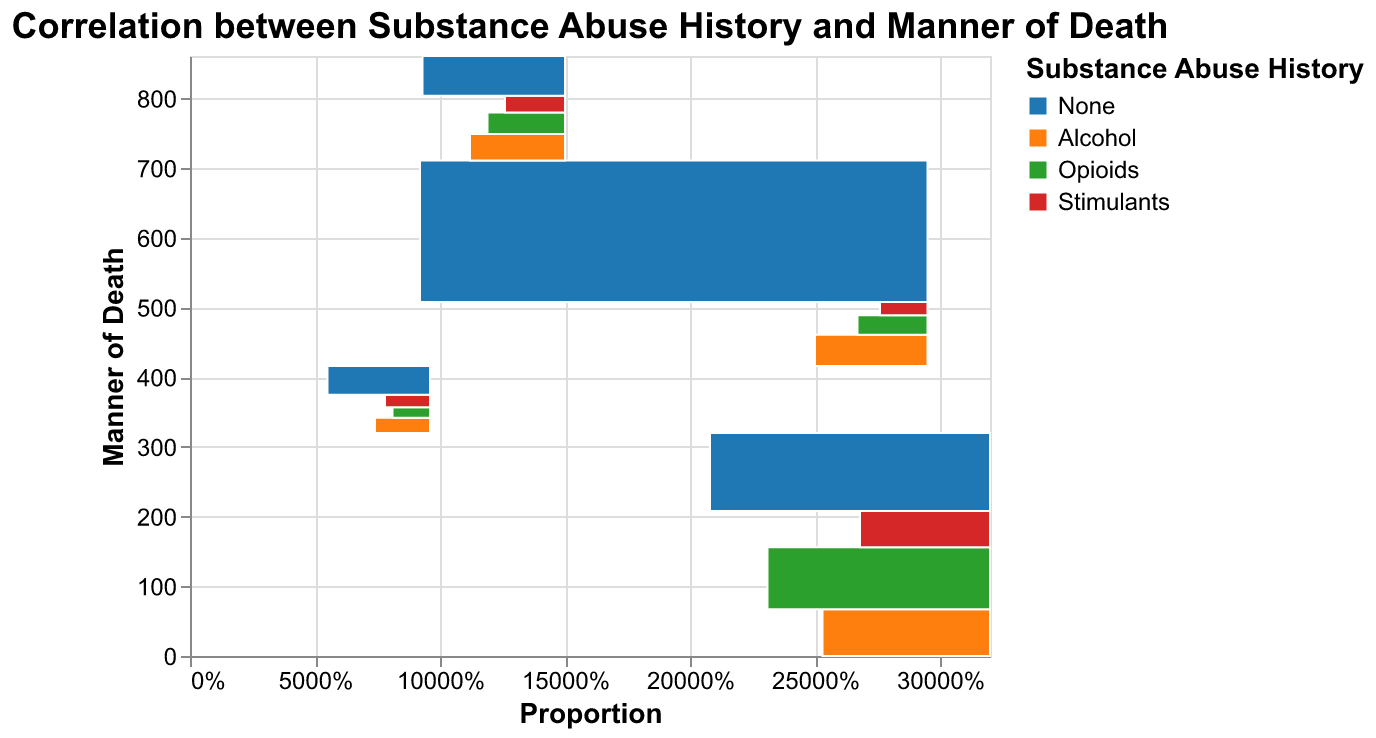What is the title of the figure? The title of the figure is typically found at the top of the chart, serving as an overview of what the chart is about. In this case, the title is "Correlation between Substance Abuse History and Manner of Death."
Answer: Correlation between Substance Abuse History and Manner of Death Which manner of death has the highest count associated with no substance abuse? By looking at the section of the plot representing 'None' under the 'Substance Abuse History', observe the different manners of death. The highest count bar will be the tallest one.
Answer: Natural What is the total count for accidental deaths with any substance abuse history? Sum the individual counts for accidental deaths that have either Alcohol, Opioids, or Stimulants in their substance abuse history. These counts are 67 + 89 + 52.
Answer: 208 Compare the proportions of deaths involving opioid abuse for accidental vs. suicide manners. Which is higher? Compare the heights of the 'Opioids' sections for 'Accidental' and 'Suicide' manners of death. The taller bar will indicate the higher proportion.
Answer: Accidental How does the count for natural deaths without any substance abuse compare to suicide deaths without any substance abuse? Locate the 'None' sections under 'Natural' and 'Suicide' manners of death, then note their counts. Compare these counts directly (203 for Natural vs. 57 for Suicide).
Answer: Natural is higher Which substance abuse has the least association with accidental deaths? Check the counts for all substances (Alcohol, Opioids, Stimulants) under the 'Accidental' manner of death and identify the one with the smallest count.
Answer: Stimulants What proportion of natural deaths involves alcohol abuse? Calculate the proportion by dividing the count of natural deaths with alcohol abuse by the total count of natural deaths. The counts are 45 (Alcohol) out of (45 + 28 + 19 + 203).
Answer: 45/295 Compare the count of alcohol abuse in homicides to suicides. Locate the counts for 'Alcohol' in both 'Homicide' and 'Suicide' manners of death and compare them directly (22 for Homicide vs. 38 for Suicide).
Answer: Suicide is higher How do accidental deaths with no substance abuse history compare in proportion to those with opioid abuse? For 'Accidental' deaths, compare the sections representing 'None' and 'Opioids'. Respective counts need conversion to percentages for a clear comparison.
Answer: Opioids are higher 